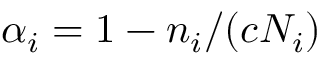Convert formula to latex. <formula><loc_0><loc_0><loc_500><loc_500>\alpha _ { i } = 1 - n _ { i } / ( c N _ { i } )</formula> 